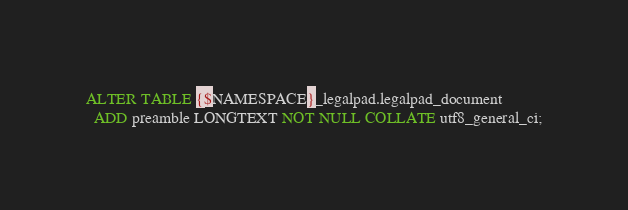Convert code to text. <code><loc_0><loc_0><loc_500><loc_500><_SQL_>ALTER TABLE {$NAMESPACE}_legalpad.legalpad_document
  ADD preamble LONGTEXT NOT NULL COLLATE utf8_general_ci;
</code> 